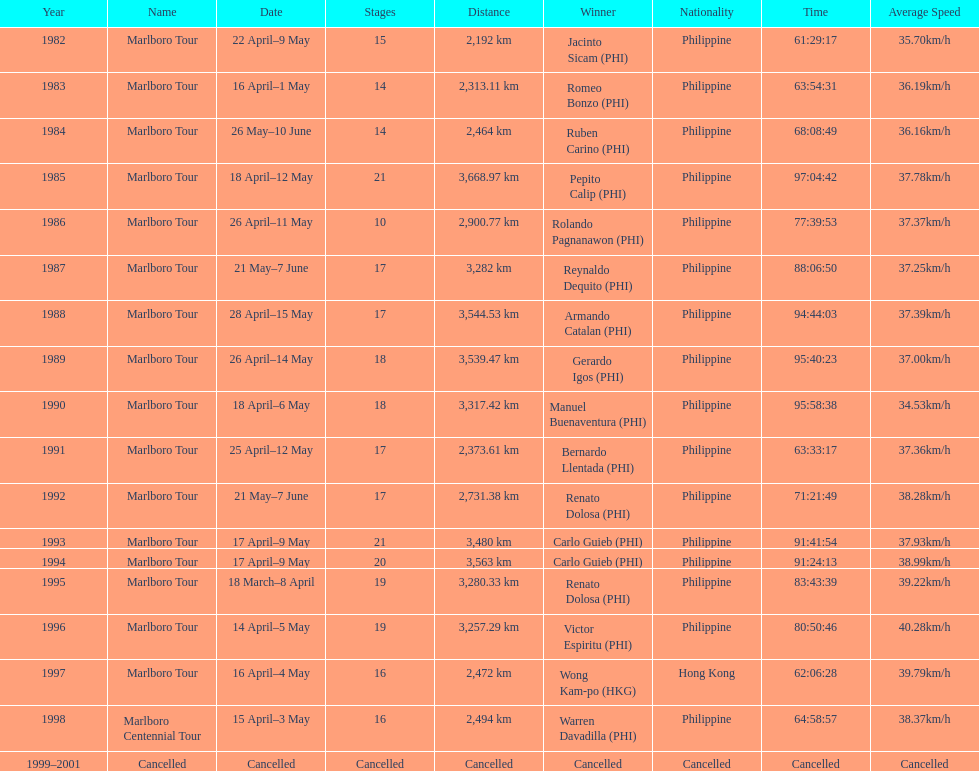How many marlboro tours did carlo guieb win? 2. Could you help me parse every detail presented in this table? {'header': ['Year', 'Name', 'Date', 'Stages', 'Distance', 'Winner', 'Nationality', 'Time', 'Average Speed'], 'rows': [['1982', 'Marlboro Tour', '22 April–9 May', '15', '2,192\xa0km', 'Jacinto Sicam\xa0(PHI)', 'Philippine', '61:29:17', '35.70km/h'], ['1983', 'Marlboro Tour', '16 April–1 May', '14', '2,313.11\xa0km', 'Romeo Bonzo\xa0(PHI)', 'Philippine', '63:54:31', '36.19km/h'], ['1984', 'Marlboro Tour', '26 May–10 June', '14', '2,464\xa0km', 'Ruben Carino\xa0(PHI)', 'Philippine', '68:08:49', '36.16km/h'], ['1985', 'Marlboro Tour', '18 April–12 May', '21', '3,668.97\xa0km', 'Pepito Calip\xa0(PHI)', 'Philippine', '97:04:42', '37.78km/h'], ['1986', 'Marlboro Tour', '26 April–11 May', '10', '2,900.77\xa0km', 'Rolando Pagnanawon\xa0(PHI)', 'Philippine', '77:39:53', '37.37km/h'], ['1987', 'Marlboro Tour', '21 May–7 June', '17', '3,282\xa0km', 'Reynaldo Dequito\xa0(PHI)', 'Philippine', '88:06:50', '37.25km/h'], ['1988', 'Marlboro Tour', '28 April–15 May', '17', '3,544.53\xa0km', 'Armando Catalan\xa0(PHI)', 'Philippine', '94:44:03', '37.39km/h'], ['1989', 'Marlboro Tour', '26 April–14 May', '18', '3,539.47\xa0km', 'Gerardo Igos\xa0(PHI)', 'Philippine', '95:40:23', '37.00km/h'], ['1990', 'Marlboro Tour', '18 April–6 May', '18', '3,317.42\xa0km', 'Manuel Buenaventura\xa0(PHI)', 'Philippine', '95:58:38', '34.53km/h'], ['1991', 'Marlboro Tour', '25 April–12 May', '17', '2,373.61\xa0km', 'Bernardo Llentada\xa0(PHI)', 'Philippine', '63:33:17', '37.36km/h'], ['1992', 'Marlboro Tour', '21 May–7 June', '17', '2,731.38\xa0km', 'Renato Dolosa\xa0(PHI)', 'Philippine', '71:21:49', '38.28km/h'], ['1993', 'Marlboro Tour', '17 April–9 May', '21', '3,480\xa0km', 'Carlo Guieb\xa0(PHI)', 'Philippine', '91:41:54', '37.93km/h'], ['1994', 'Marlboro Tour', '17 April–9 May', '20', '3,563\xa0km', 'Carlo Guieb\xa0(PHI)', 'Philippine', '91:24:13', '38.99km/h'], ['1995', 'Marlboro Tour', '18 March–8 April', '19', '3,280.33\xa0km', 'Renato Dolosa\xa0(PHI)', 'Philippine', '83:43:39', '39.22km/h'], ['1996', 'Marlboro Tour', '14 April–5 May', '19', '3,257.29\xa0km', 'Victor Espiritu\xa0(PHI)', 'Philippine', '80:50:46', '40.28km/h'], ['1997', 'Marlboro Tour', '16 April–4 May', '16', '2,472\xa0km', 'Wong Kam-po\xa0(HKG)', 'Hong Kong', '62:06:28', '39.79km/h'], ['1998', 'Marlboro Centennial Tour', '15 April–3 May', '16', '2,494\xa0km', 'Warren Davadilla\xa0(PHI)', 'Philippine', '64:58:57', '38.37km/h'], ['1999–2001', 'Cancelled', 'Cancelled', 'Cancelled', 'Cancelled', 'Cancelled', 'Cancelled', 'Cancelled', 'Cancelled']]} 